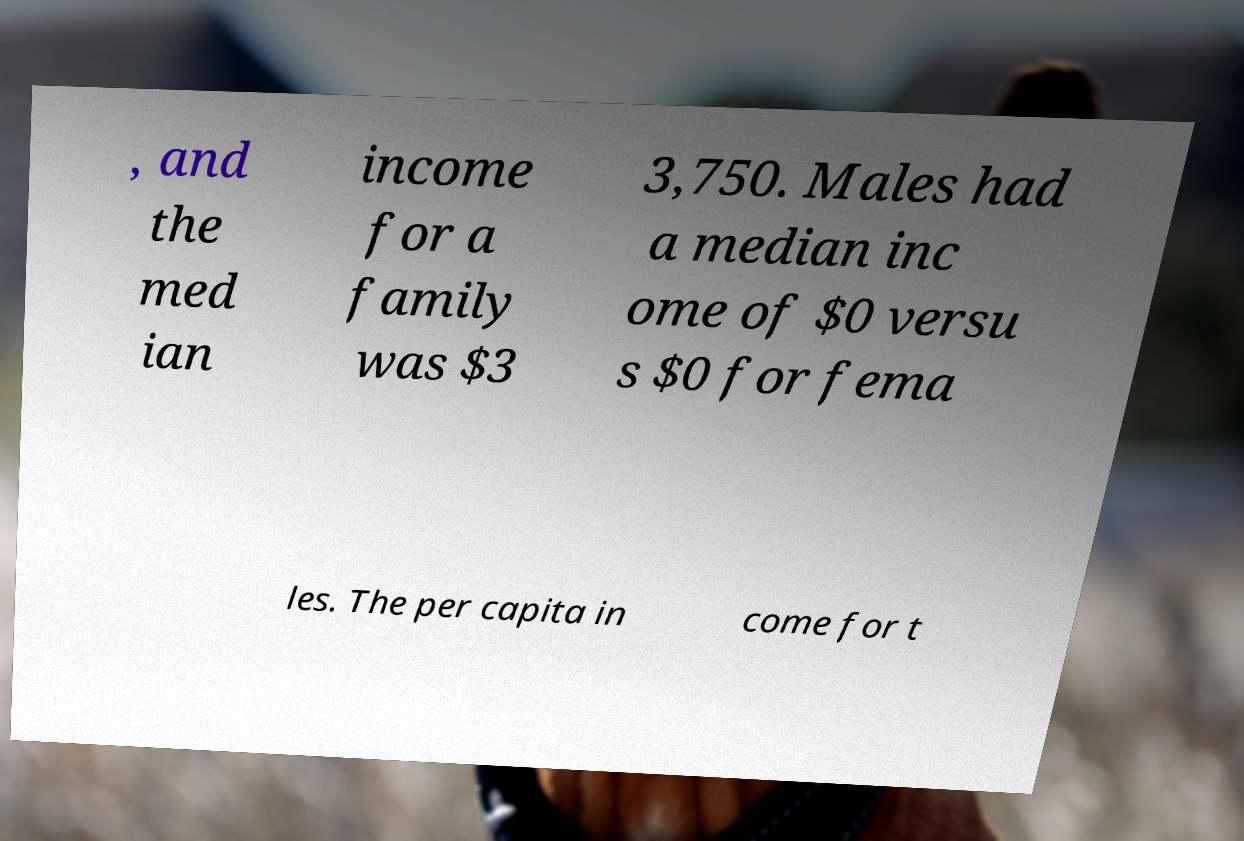What messages or text are displayed in this image? I need them in a readable, typed format. , and the med ian income for a family was $3 3,750. Males had a median inc ome of $0 versu s $0 for fema les. The per capita in come for t 